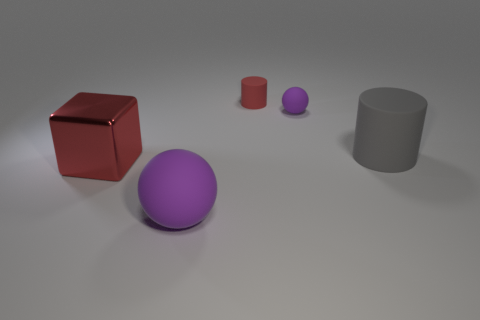Add 3 large purple spheres. How many objects exist? 8 Subtract 1 cylinders. How many cylinders are left? 1 Subtract all brown cubes. Subtract all gray cylinders. How many cubes are left? 1 Subtract all red spheres. How many red cylinders are left? 1 Subtract all big things. Subtract all tiny brown things. How many objects are left? 2 Add 2 large spheres. How many large spheres are left? 3 Add 5 small red cylinders. How many small red cylinders exist? 6 Subtract all gray cylinders. How many cylinders are left? 1 Subtract 0 yellow spheres. How many objects are left? 5 Subtract all spheres. How many objects are left? 3 